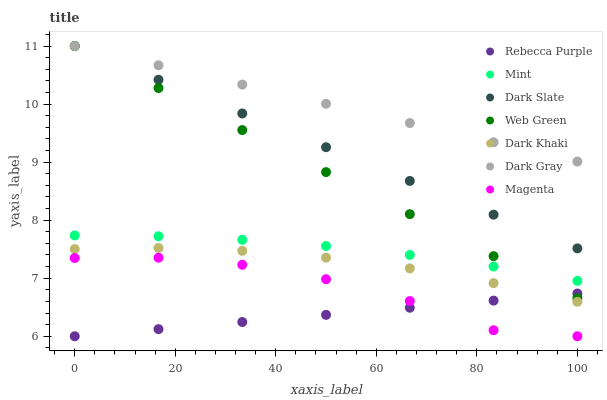Does Rebecca Purple have the minimum area under the curve?
Answer yes or no. Yes. Does Dark Gray have the maximum area under the curve?
Answer yes or no. Yes. Does Web Green have the minimum area under the curve?
Answer yes or no. No. Does Web Green have the maximum area under the curve?
Answer yes or no. No. Is Dark Gray the smoothest?
Answer yes or no. Yes. Is Magenta the roughest?
Answer yes or no. Yes. Is Web Green the smoothest?
Answer yes or no. No. Is Web Green the roughest?
Answer yes or no. No. Does Rebecca Purple have the lowest value?
Answer yes or no. Yes. Does Web Green have the lowest value?
Answer yes or no. No. Does Dark Slate have the highest value?
Answer yes or no. Yes. Does Dark Khaki have the highest value?
Answer yes or no. No. Is Magenta less than Dark Khaki?
Answer yes or no. Yes. Is Dark Gray greater than Mint?
Answer yes or no. Yes. Does Rebecca Purple intersect Web Green?
Answer yes or no. Yes. Is Rebecca Purple less than Web Green?
Answer yes or no. No. Is Rebecca Purple greater than Web Green?
Answer yes or no. No. Does Magenta intersect Dark Khaki?
Answer yes or no. No. 